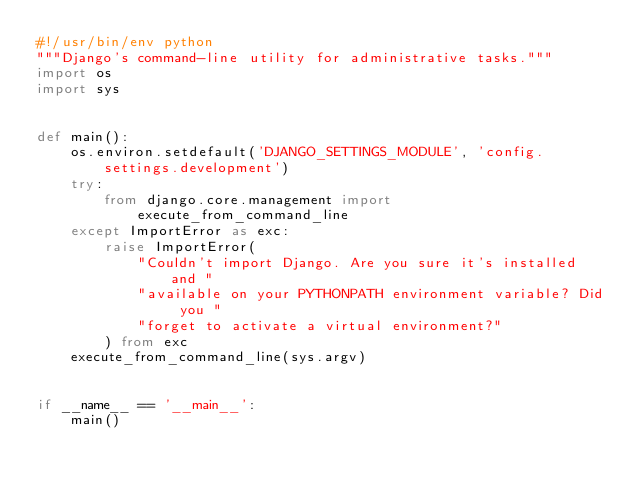<code> <loc_0><loc_0><loc_500><loc_500><_Python_>#!/usr/bin/env python
"""Django's command-line utility for administrative tasks."""
import os
import sys


def main():
    os.environ.setdefault('DJANGO_SETTINGS_MODULE', 'config.settings.development')
    try:
        from django.core.management import execute_from_command_line
    except ImportError as exc:
        raise ImportError(
            "Couldn't import Django. Are you sure it's installed and "
            "available on your PYTHONPATH environment variable? Did you "
            "forget to activate a virtual environment?"
        ) from exc
    execute_from_command_line(sys.argv)


if __name__ == '__main__':
    main()</code> 